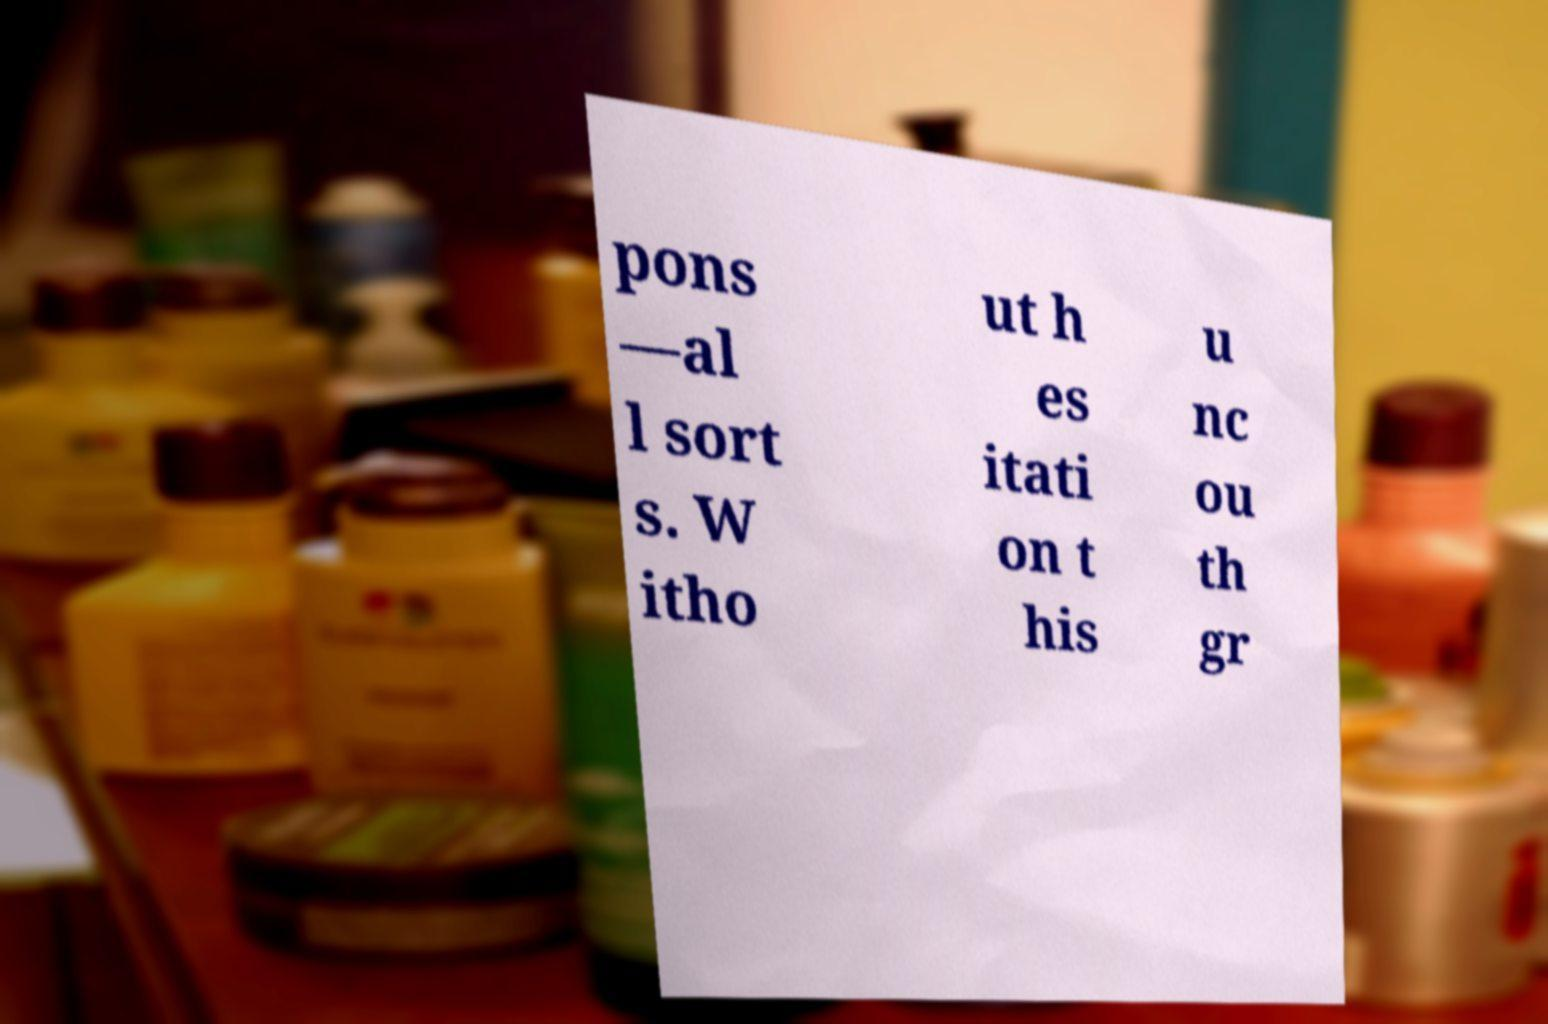Could you assist in decoding the text presented in this image and type it out clearly? pons —al l sort s. W itho ut h es itati on t his u nc ou th gr 